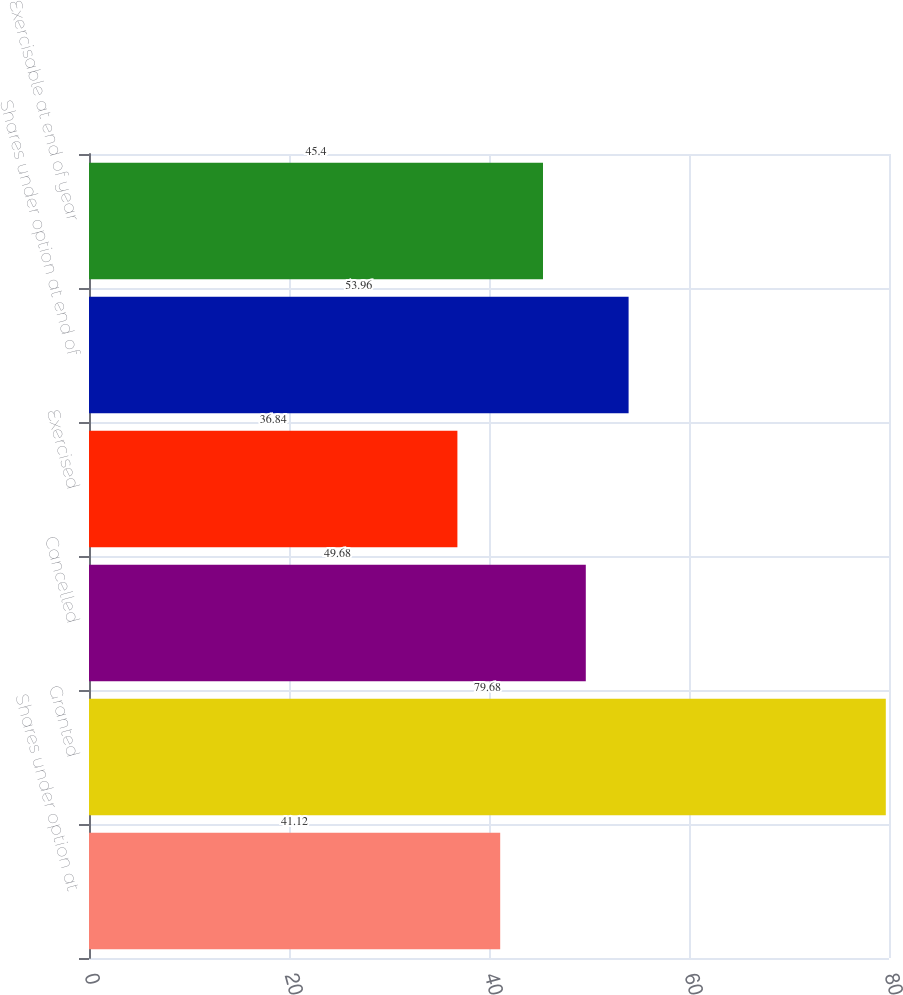Convert chart. <chart><loc_0><loc_0><loc_500><loc_500><bar_chart><fcel>Shares under option at<fcel>Granted<fcel>Cancelled<fcel>Exercised<fcel>Shares under option at end of<fcel>Exercisable at end of year<nl><fcel>41.12<fcel>79.68<fcel>49.68<fcel>36.84<fcel>53.96<fcel>45.4<nl></chart> 